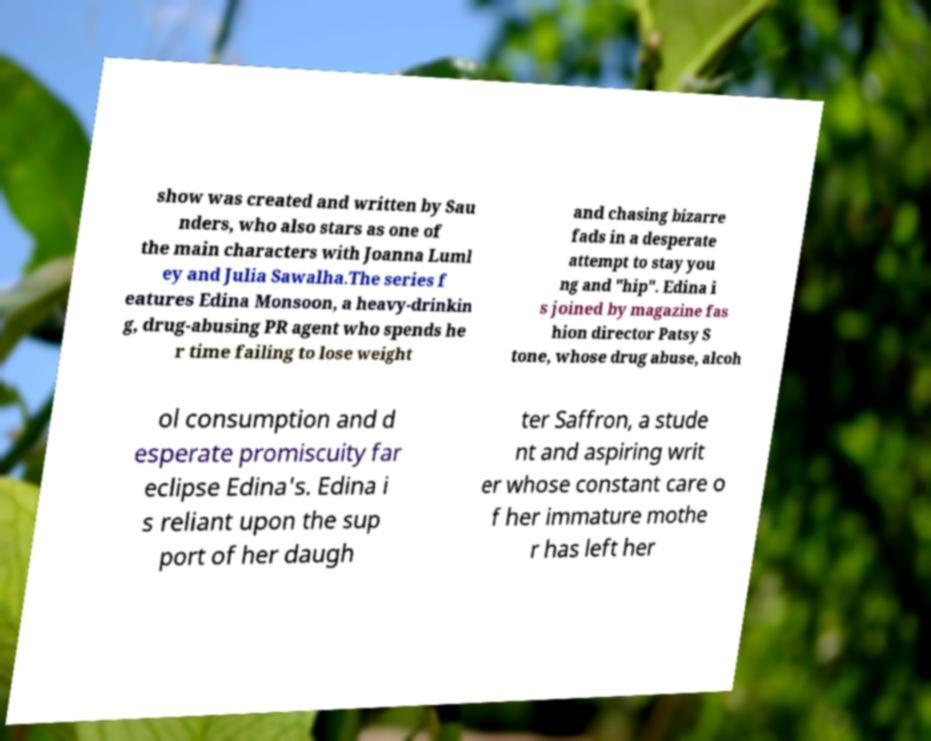There's text embedded in this image that I need extracted. Can you transcribe it verbatim? show was created and written by Sau nders, who also stars as one of the main characters with Joanna Luml ey and Julia Sawalha.The series f eatures Edina Monsoon, a heavy-drinkin g, drug-abusing PR agent who spends he r time failing to lose weight and chasing bizarre fads in a desperate attempt to stay you ng and "hip". Edina i s joined by magazine fas hion director Patsy S tone, whose drug abuse, alcoh ol consumption and d esperate promiscuity far eclipse Edina's. Edina i s reliant upon the sup port of her daugh ter Saffron, a stude nt and aspiring writ er whose constant care o f her immature mothe r has left her 